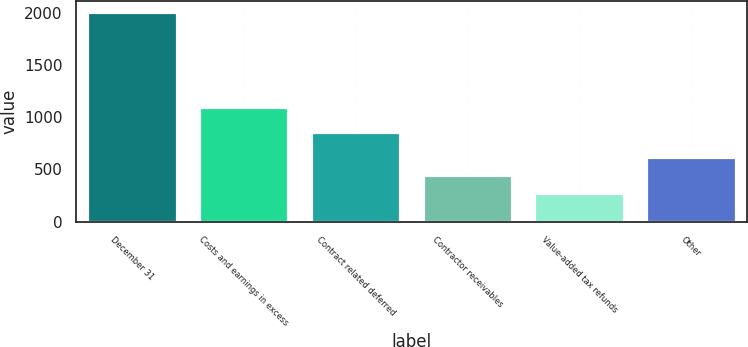<chart> <loc_0><loc_0><loc_500><loc_500><bar_chart><fcel>December 31<fcel>Costs and earnings in excess<fcel>Contract related deferred<fcel>Contractor receivables<fcel>Value-added tax refunds<fcel>Other<nl><fcel>2008<fcel>1094<fcel>861<fcel>451<fcel>278<fcel>624<nl></chart> 